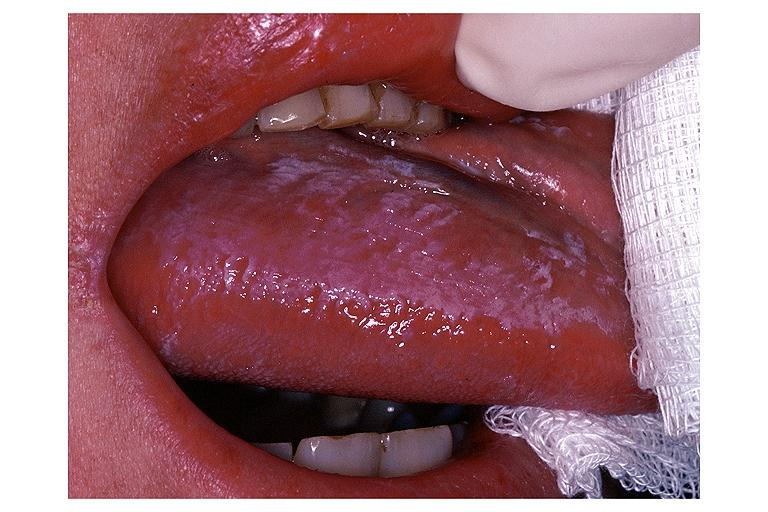what is present?
Answer the question using a single word or phrase. Oral 